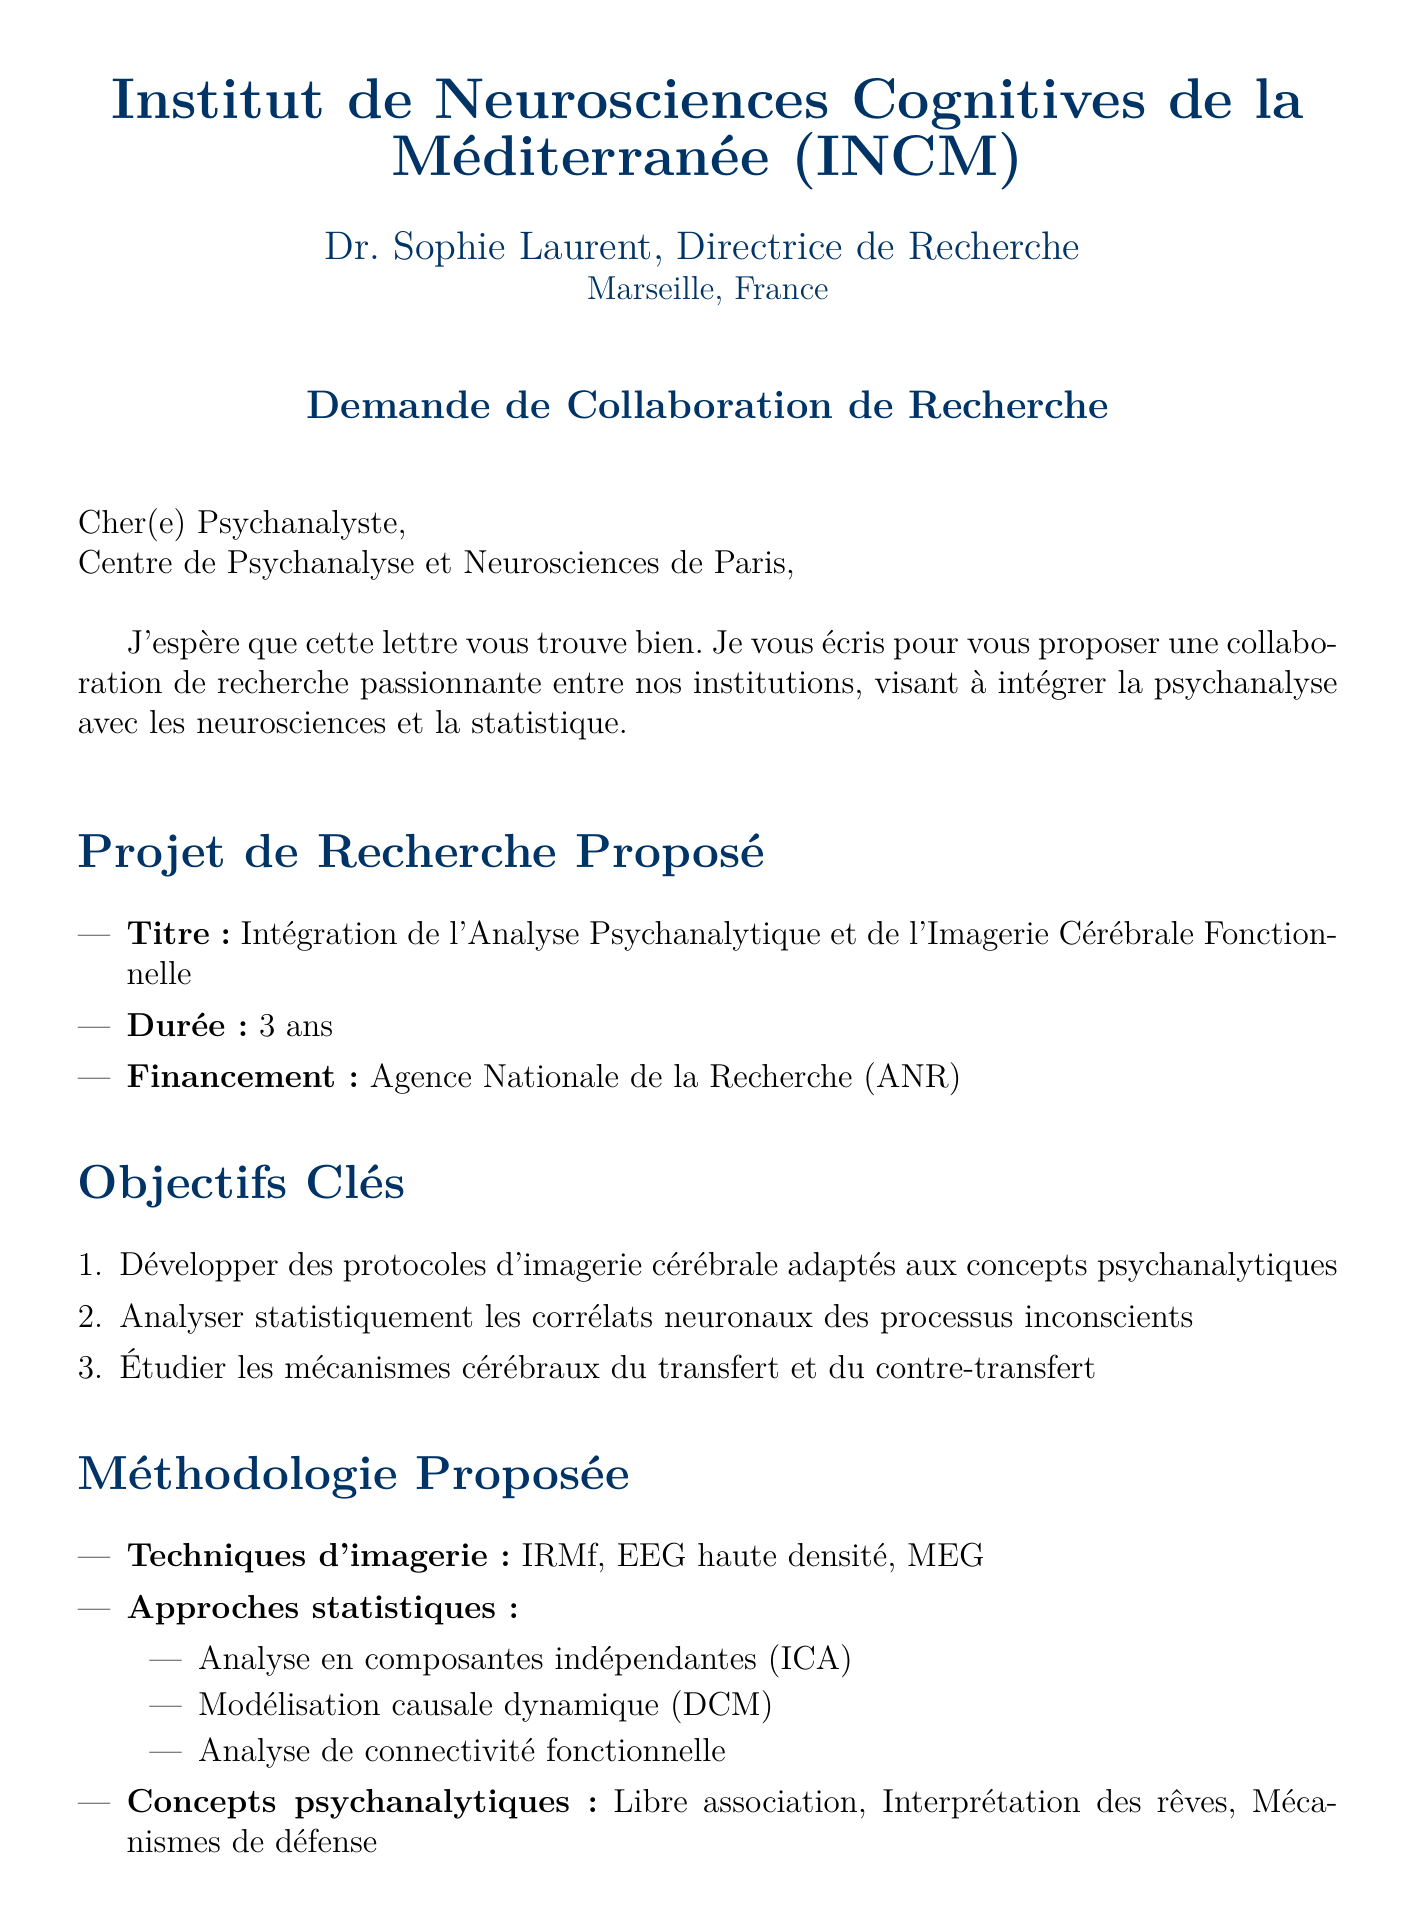Quel est le titre du projet proposé ? Le titre du projet proposé est mentionné dans la section des détails du projet.
Answer: Intégration de l'Analyse Psychanalytique et de l'Imagerie Cérébrale Fonctionnelle Quelle est la durée du projet ? La durée du projet est spécifiée dans les détails du projet.
Answer: 3 ans Qui est l'expéditeur de la lettre ? L'expéditeur est mentionné dans les informations de l'expéditeur au début de la lettre.
Answer: Dr. Sophie Laurent Quels types de techniques d'imagerie sont proposés ? Les techniques d'imagerie sont énumérées dans la section de méthodologie proposée.
Answer: IRMf, EEG haute densité, MEG Quel organisme finance le projet ? Le financement du projet est mentionné dans les détails du projet.
Answer: Agence Nationale de la Recherche (ANR) Quels sont les avantages de la collaboration ? Les avantages de la collaboration sont listés dans la section dédiée.
Answer: Accès à l'IRM fonctionnelle 7 Tesla de l'INCM Combien de phases sont prévues dans le calendrier du projet ? Le calendrier du projet présente plusieurs phases distinctes.
Answer: 4 Quelles sont les considérations éthiques requises ? Les considérations éthiques sont mentionnées dans la section prévue à cet effet.
Answer: Approbation du comité d'éthique de l'Université Aix-Marseille Quel est le titre de l'institut de recherche de l'expéditeur ? Le titre de l'institut est donné dans les informations sur l'expéditeur.
Answer: Institut de Neurosciences Cognitives de la Méditerranée (INCM) 